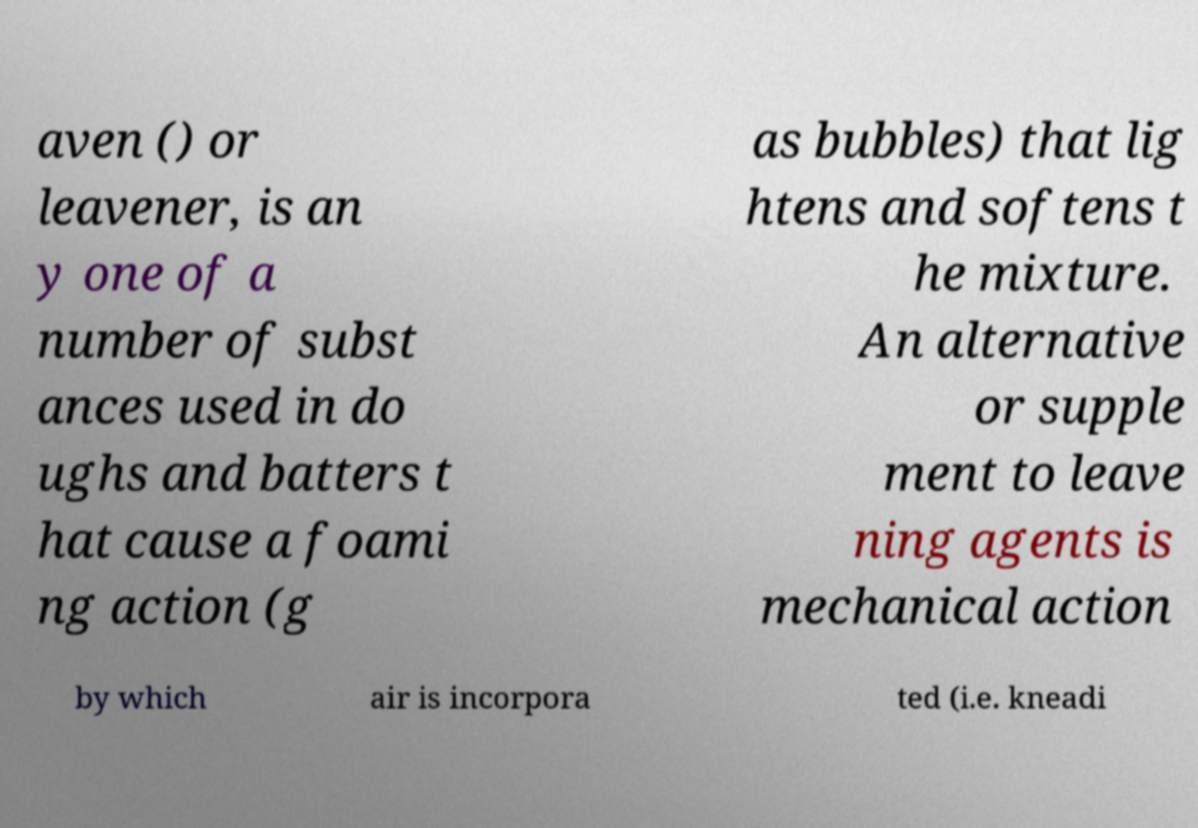Could you assist in decoding the text presented in this image and type it out clearly? aven () or leavener, is an y one of a number of subst ances used in do ughs and batters t hat cause a foami ng action (g as bubbles) that lig htens and softens t he mixture. An alternative or supple ment to leave ning agents is mechanical action by which air is incorpora ted (i.e. kneadi 